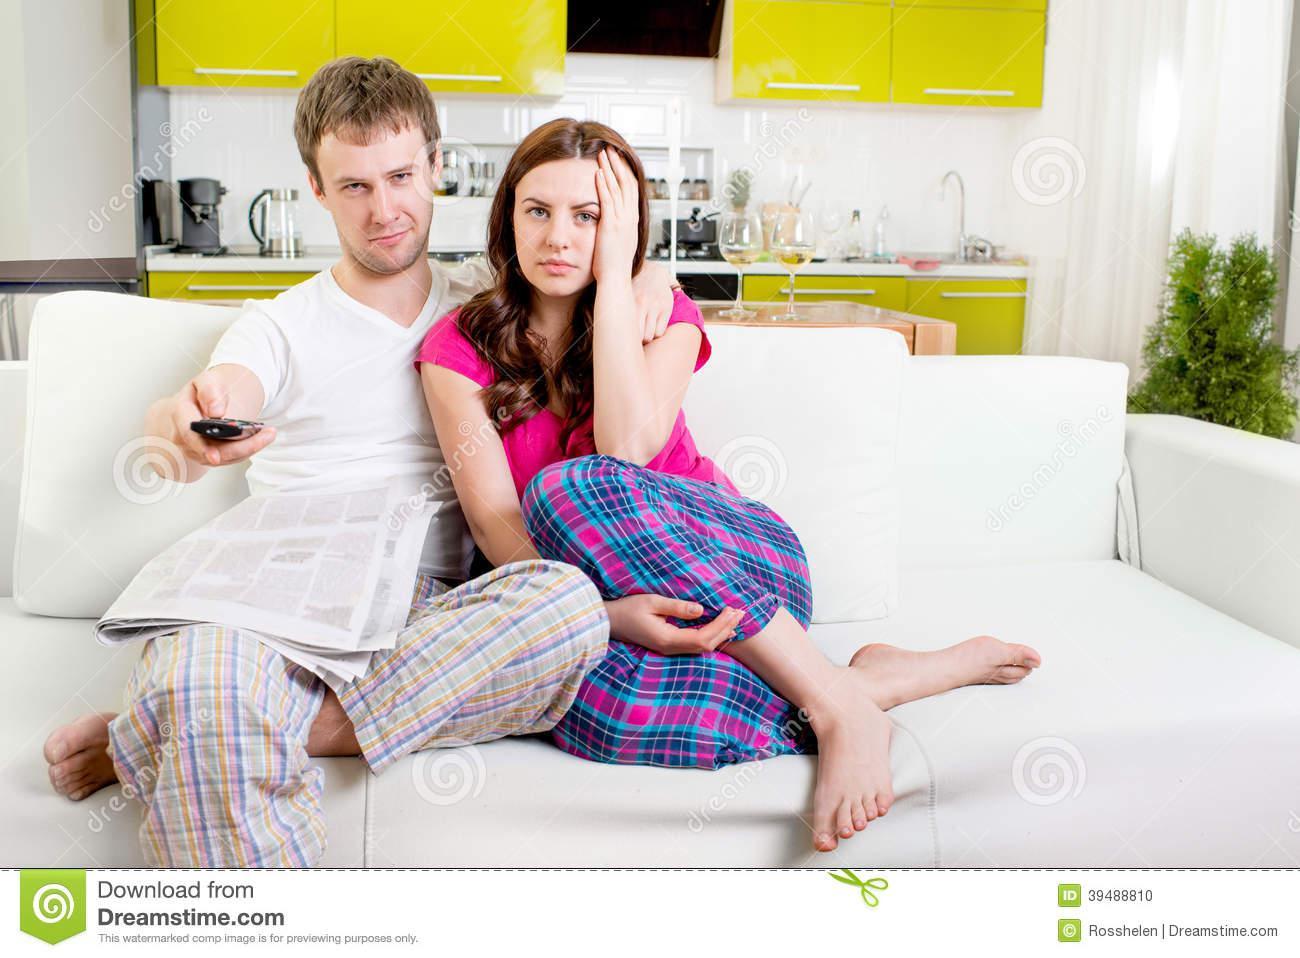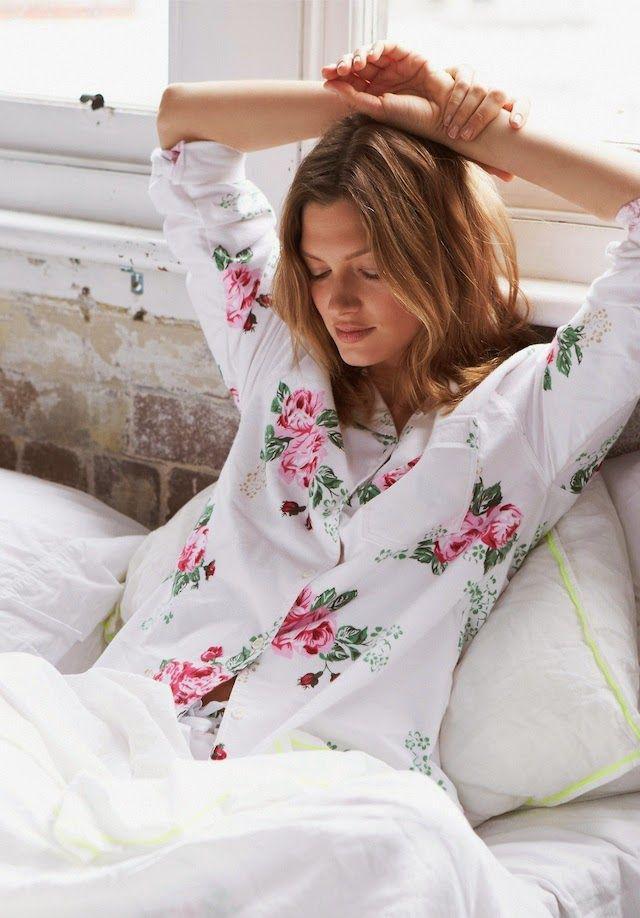The first image is the image on the left, the second image is the image on the right. For the images shown, is this caption "An image shows a child in sleepwear near a stuffed animal, with no adult present." true? Answer yes or no. No. The first image is the image on the left, the second image is the image on the right. Given the left and right images, does the statement "In one of the pictures, there is a smiling child with a stuffed animal near it, and in the other picture there is a woman alone." hold true? Answer yes or no. No. 